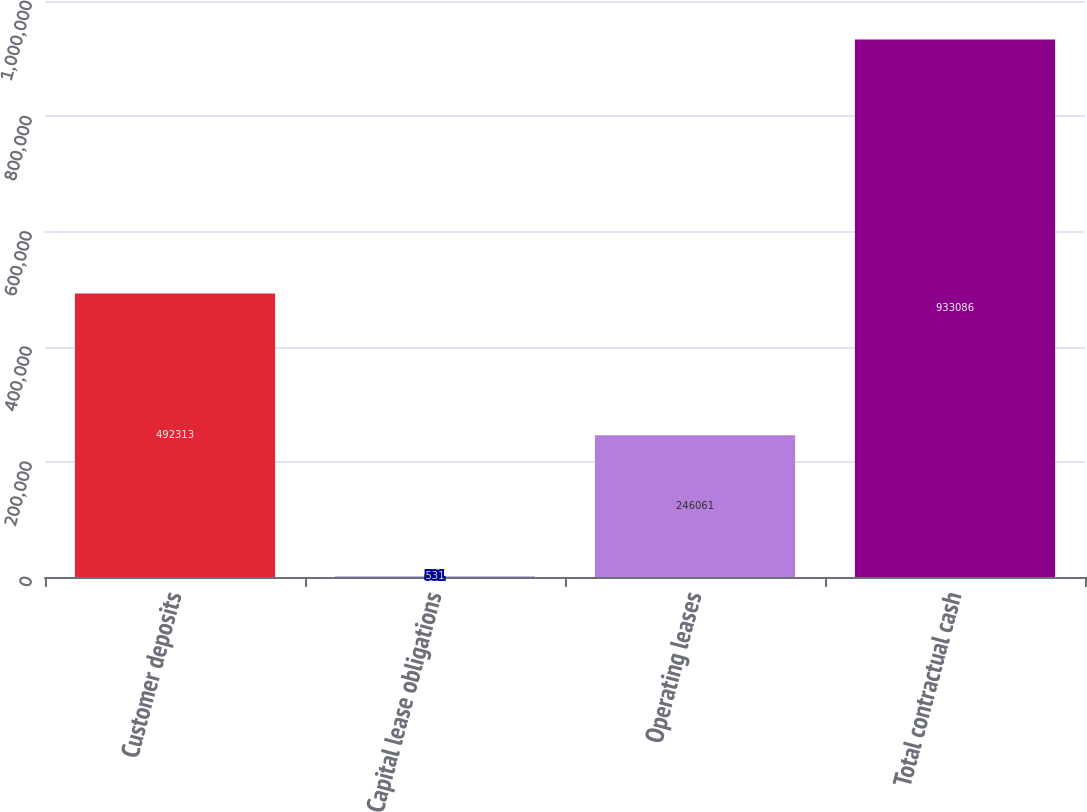Convert chart. <chart><loc_0><loc_0><loc_500><loc_500><bar_chart><fcel>Customer deposits<fcel>Capital lease obligations<fcel>Operating leases<fcel>Total contractual cash<nl><fcel>492313<fcel>531<fcel>246061<fcel>933086<nl></chart> 